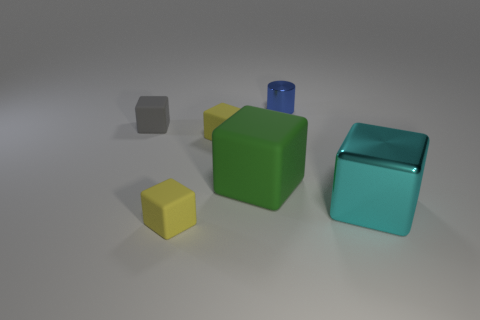There is a big thing that is to the left of the blue thing; is it the same color as the tiny cylinder?
Provide a succinct answer. No. Is there anything else that has the same shape as the tiny blue shiny thing?
Your answer should be very brief. No. Are there any small yellow objects behind the small blue metallic thing behind the green rubber thing?
Offer a terse response. No. Is the number of big objects left of the blue cylinder less than the number of tiny things behind the large cyan metallic object?
Offer a very short reply. Yes. What size is the rubber thing that is to the left of the yellow cube that is in front of the big cube that is in front of the large green object?
Your response must be concise. Small. There is a object that is behind the gray matte cube; is it the same size as the big rubber block?
Make the answer very short. No. What number of other things are the same material as the cyan object?
Offer a terse response. 1. Are there more large metal things than yellow shiny blocks?
Make the answer very short. Yes. What material is the tiny cube on the left side of the small yellow rubber thing in front of the yellow matte block that is behind the cyan object made of?
Your response must be concise. Rubber. What shape is the gray matte object that is the same size as the blue thing?
Offer a very short reply. Cube. 